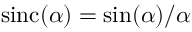<formula> <loc_0><loc_0><loc_500><loc_500>\sin c ( \alpha ) = \sin ( \alpha ) / \alpha</formula> 